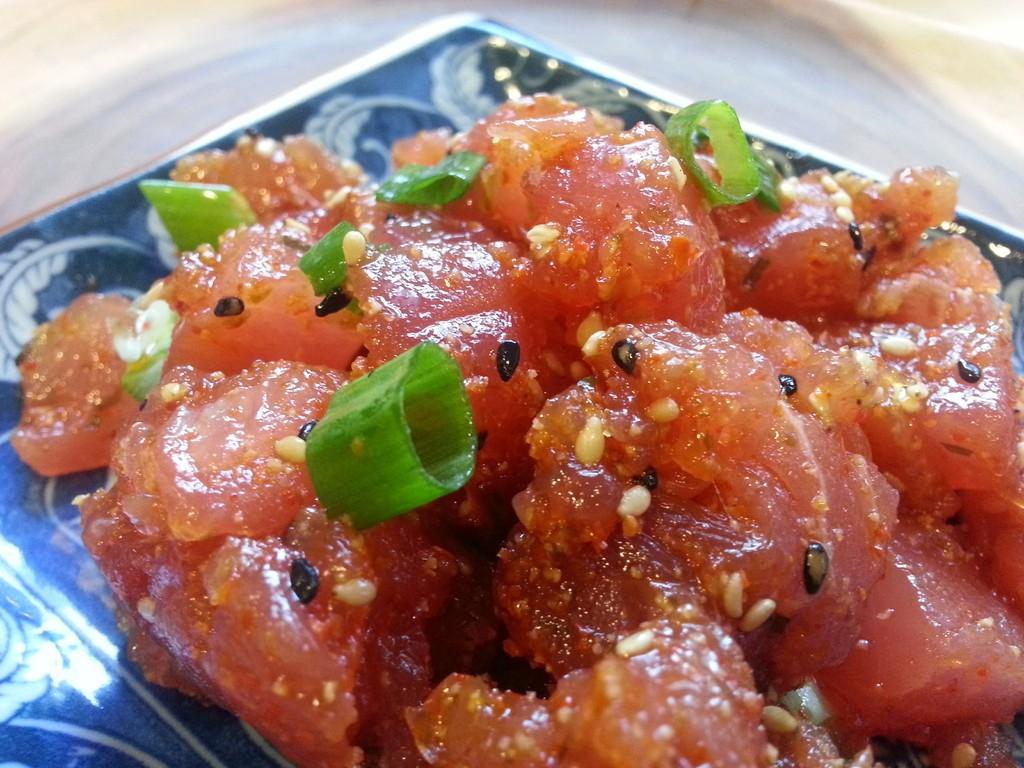How would you summarize this image in a sentence or two? In this image I can see a plate , on top of plate I can see food item. 